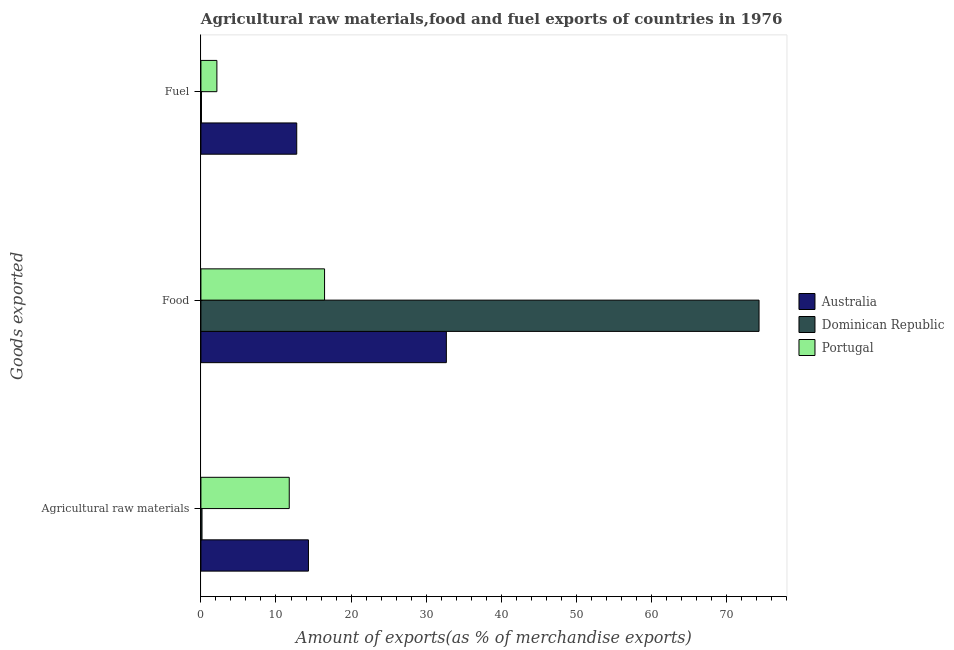How many different coloured bars are there?
Provide a short and direct response. 3. Are the number of bars per tick equal to the number of legend labels?
Your response must be concise. Yes. Are the number of bars on each tick of the Y-axis equal?
Your answer should be compact. Yes. How many bars are there on the 3rd tick from the bottom?
Provide a short and direct response. 3. What is the label of the 3rd group of bars from the top?
Provide a succinct answer. Agricultural raw materials. What is the percentage of food exports in Australia?
Give a very brief answer. 32.7. Across all countries, what is the maximum percentage of raw materials exports?
Provide a short and direct response. 14.33. Across all countries, what is the minimum percentage of fuel exports?
Your answer should be compact. 0.07. In which country was the percentage of food exports minimum?
Offer a very short reply. Portugal. What is the total percentage of raw materials exports in the graph?
Provide a short and direct response. 26.24. What is the difference between the percentage of raw materials exports in Portugal and that in Dominican Republic?
Make the answer very short. 11.62. What is the difference between the percentage of fuel exports in Australia and the percentage of food exports in Dominican Republic?
Give a very brief answer. -61.59. What is the average percentage of food exports per country?
Offer a very short reply. 41.17. What is the difference between the percentage of fuel exports and percentage of food exports in Australia?
Keep it short and to the point. -19.93. What is the ratio of the percentage of raw materials exports in Australia to that in Portugal?
Keep it short and to the point. 1.22. What is the difference between the highest and the second highest percentage of raw materials exports?
Offer a terse response. 2.56. What is the difference between the highest and the lowest percentage of raw materials exports?
Your answer should be very brief. 14.18. In how many countries, is the percentage of fuel exports greater than the average percentage of fuel exports taken over all countries?
Provide a short and direct response. 1. What does the 3rd bar from the top in Fuel represents?
Your response must be concise. Australia. What does the 3rd bar from the bottom in Fuel represents?
Provide a short and direct response. Portugal. Is it the case that in every country, the sum of the percentage of raw materials exports and percentage of food exports is greater than the percentage of fuel exports?
Make the answer very short. Yes. Does the graph contain any zero values?
Make the answer very short. No. Does the graph contain grids?
Your response must be concise. No. Where does the legend appear in the graph?
Offer a terse response. Center right. How many legend labels are there?
Ensure brevity in your answer.  3. How are the legend labels stacked?
Provide a succinct answer. Vertical. What is the title of the graph?
Make the answer very short. Agricultural raw materials,food and fuel exports of countries in 1976. Does "Guam" appear as one of the legend labels in the graph?
Your answer should be compact. No. What is the label or title of the X-axis?
Your answer should be very brief. Amount of exports(as % of merchandise exports). What is the label or title of the Y-axis?
Offer a very short reply. Goods exported. What is the Amount of exports(as % of merchandise exports) in Australia in Agricultural raw materials?
Your response must be concise. 14.33. What is the Amount of exports(as % of merchandise exports) in Dominican Republic in Agricultural raw materials?
Offer a terse response. 0.15. What is the Amount of exports(as % of merchandise exports) of Portugal in Agricultural raw materials?
Provide a short and direct response. 11.77. What is the Amount of exports(as % of merchandise exports) in Australia in Food?
Your answer should be very brief. 32.7. What is the Amount of exports(as % of merchandise exports) in Dominican Republic in Food?
Your answer should be compact. 74.35. What is the Amount of exports(as % of merchandise exports) of Portugal in Food?
Keep it short and to the point. 16.47. What is the Amount of exports(as % of merchandise exports) in Australia in Fuel?
Make the answer very short. 12.76. What is the Amount of exports(as % of merchandise exports) of Dominican Republic in Fuel?
Your response must be concise. 0.07. What is the Amount of exports(as % of merchandise exports) in Portugal in Fuel?
Provide a succinct answer. 2.13. Across all Goods exported, what is the maximum Amount of exports(as % of merchandise exports) of Australia?
Keep it short and to the point. 32.7. Across all Goods exported, what is the maximum Amount of exports(as % of merchandise exports) of Dominican Republic?
Keep it short and to the point. 74.35. Across all Goods exported, what is the maximum Amount of exports(as % of merchandise exports) of Portugal?
Make the answer very short. 16.47. Across all Goods exported, what is the minimum Amount of exports(as % of merchandise exports) in Australia?
Provide a short and direct response. 12.76. Across all Goods exported, what is the minimum Amount of exports(as % of merchandise exports) in Dominican Republic?
Provide a succinct answer. 0.07. Across all Goods exported, what is the minimum Amount of exports(as % of merchandise exports) in Portugal?
Your answer should be very brief. 2.13. What is the total Amount of exports(as % of merchandise exports) in Australia in the graph?
Offer a terse response. 59.78. What is the total Amount of exports(as % of merchandise exports) in Dominican Republic in the graph?
Offer a terse response. 74.56. What is the total Amount of exports(as % of merchandise exports) of Portugal in the graph?
Your answer should be very brief. 30.37. What is the difference between the Amount of exports(as % of merchandise exports) in Australia in Agricultural raw materials and that in Food?
Keep it short and to the point. -18.37. What is the difference between the Amount of exports(as % of merchandise exports) of Dominican Republic in Agricultural raw materials and that in Food?
Make the answer very short. -74.2. What is the difference between the Amount of exports(as % of merchandise exports) of Portugal in Agricultural raw materials and that in Food?
Give a very brief answer. -4.71. What is the difference between the Amount of exports(as % of merchandise exports) of Australia in Agricultural raw materials and that in Fuel?
Provide a short and direct response. 1.56. What is the difference between the Amount of exports(as % of merchandise exports) in Dominican Republic in Agricultural raw materials and that in Fuel?
Keep it short and to the point. 0.08. What is the difference between the Amount of exports(as % of merchandise exports) of Portugal in Agricultural raw materials and that in Fuel?
Keep it short and to the point. 9.64. What is the difference between the Amount of exports(as % of merchandise exports) of Australia in Food and that in Fuel?
Make the answer very short. 19.93. What is the difference between the Amount of exports(as % of merchandise exports) of Dominican Republic in Food and that in Fuel?
Make the answer very short. 74.28. What is the difference between the Amount of exports(as % of merchandise exports) of Portugal in Food and that in Fuel?
Make the answer very short. 14.34. What is the difference between the Amount of exports(as % of merchandise exports) in Australia in Agricultural raw materials and the Amount of exports(as % of merchandise exports) in Dominican Republic in Food?
Offer a very short reply. -60.02. What is the difference between the Amount of exports(as % of merchandise exports) in Australia in Agricultural raw materials and the Amount of exports(as % of merchandise exports) in Portugal in Food?
Give a very brief answer. -2.15. What is the difference between the Amount of exports(as % of merchandise exports) of Dominican Republic in Agricultural raw materials and the Amount of exports(as % of merchandise exports) of Portugal in Food?
Offer a very short reply. -16.33. What is the difference between the Amount of exports(as % of merchandise exports) of Australia in Agricultural raw materials and the Amount of exports(as % of merchandise exports) of Dominican Republic in Fuel?
Give a very brief answer. 14.26. What is the difference between the Amount of exports(as % of merchandise exports) of Australia in Agricultural raw materials and the Amount of exports(as % of merchandise exports) of Portugal in Fuel?
Give a very brief answer. 12.2. What is the difference between the Amount of exports(as % of merchandise exports) of Dominican Republic in Agricultural raw materials and the Amount of exports(as % of merchandise exports) of Portugal in Fuel?
Your answer should be compact. -1.98. What is the difference between the Amount of exports(as % of merchandise exports) in Australia in Food and the Amount of exports(as % of merchandise exports) in Dominican Republic in Fuel?
Provide a short and direct response. 32.63. What is the difference between the Amount of exports(as % of merchandise exports) in Australia in Food and the Amount of exports(as % of merchandise exports) in Portugal in Fuel?
Offer a terse response. 30.57. What is the difference between the Amount of exports(as % of merchandise exports) of Dominican Republic in Food and the Amount of exports(as % of merchandise exports) of Portugal in Fuel?
Keep it short and to the point. 72.22. What is the average Amount of exports(as % of merchandise exports) in Australia per Goods exported?
Offer a terse response. 19.93. What is the average Amount of exports(as % of merchandise exports) in Dominican Republic per Goods exported?
Provide a succinct answer. 24.85. What is the average Amount of exports(as % of merchandise exports) in Portugal per Goods exported?
Offer a very short reply. 10.12. What is the difference between the Amount of exports(as % of merchandise exports) of Australia and Amount of exports(as % of merchandise exports) of Dominican Republic in Agricultural raw materials?
Keep it short and to the point. 14.18. What is the difference between the Amount of exports(as % of merchandise exports) of Australia and Amount of exports(as % of merchandise exports) of Portugal in Agricultural raw materials?
Provide a succinct answer. 2.56. What is the difference between the Amount of exports(as % of merchandise exports) of Dominican Republic and Amount of exports(as % of merchandise exports) of Portugal in Agricultural raw materials?
Provide a succinct answer. -11.62. What is the difference between the Amount of exports(as % of merchandise exports) in Australia and Amount of exports(as % of merchandise exports) in Dominican Republic in Food?
Keep it short and to the point. -41.65. What is the difference between the Amount of exports(as % of merchandise exports) in Australia and Amount of exports(as % of merchandise exports) in Portugal in Food?
Offer a very short reply. 16.22. What is the difference between the Amount of exports(as % of merchandise exports) of Dominican Republic and Amount of exports(as % of merchandise exports) of Portugal in Food?
Keep it short and to the point. 57.88. What is the difference between the Amount of exports(as % of merchandise exports) of Australia and Amount of exports(as % of merchandise exports) of Dominican Republic in Fuel?
Ensure brevity in your answer.  12.69. What is the difference between the Amount of exports(as % of merchandise exports) of Australia and Amount of exports(as % of merchandise exports) of Portugal in Fuel?
Your answer should be compact. 10.64. What is the difference between the Amount of exports(as % of merchandise exports) in Dominican Republic and Amount of exports(as % of merchandise exports) in Portugal in Fuel?
Offer a very short reply. -2.06. What is the ratio of the Amount of exports(as % of merchandise exports) of Australia in Agricultural raw materials to that in Food?
Provide a short and direct response. 0.44. What is the ratio of the Amount of exports(as % of merchandise exports) in Dominican Republic in Agricultural raw materials to that in Food?
Ensure brevity in your answer.  0. What is the ratio of the Amount of exports(as % of merchandise exports) of Portugal in Agricultural raw materials to that in Food?
Provide a short and direct response. 0.71. What is the ratio of the Amount of exports(as % of merchandise exports) in Australia in Agricultural raw materials to that in Fuel?
Offer a very short reply. 1.12. What is the ratio of the Amount of exports(as % of merchandise exports) in Dominican Republic in Agricultural raw materials to that in Fuel?
Provide a succinct answer. 2.11. What is the ratio of the Amount of exports(as % of merchandise exports) of Portugal in Agricultural raw materials to that in Fuel?
Keep it short and to the point. 5.53. What is the ratio of the Amount of exports(as % of merchandise exports) of Australia in Food to that in Fuel?
Give a very brief answer. 2.56. What is the ratio of the Amount of exports(as % of merchandise exports) of Dominican Republic in Food to that in Fuel?
Offer a very short reply. 1075.24. What is the ratio of the Amount of exports(as % of merchandise exports) in Portugal in Food to that in Fuel?
Your response must be concise. 7.74. What is the difference between the highest and the second highest Amount of exports(as % of merchandise exports) of Australia?
Your answer should be compact. 18.37. What is the difference between the highest and the second highest Amount of exports(as % of merchandise exports) in Dominican Republic?
Keep it short and to the point. 74.2. What is the difference between the highest and the second highest Amount of exports(as % of merchandise exports) of Portugal?
Provide a short and direct response. 4.71. What is the difference between the highest and the lowest Amount of exports(as % of merchandise exports) of Australia?
Keep it short and to the point. 19.93. What is the difference between the highest and the lowest Amount of exports(as % of merchandise exports) in Dominican Republic?
Your answer should be very brief. 74.28. What is the difference between the highest and the lowest Amount of exports(as % of merchandise exports) in Portugal?
Offer a very short reply. 14.34. 